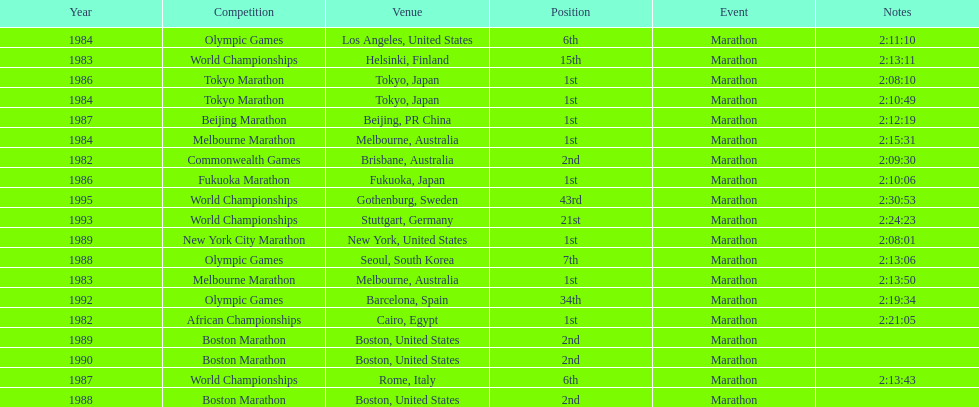What are the total number of times the position of 1st place was earned? 8. 